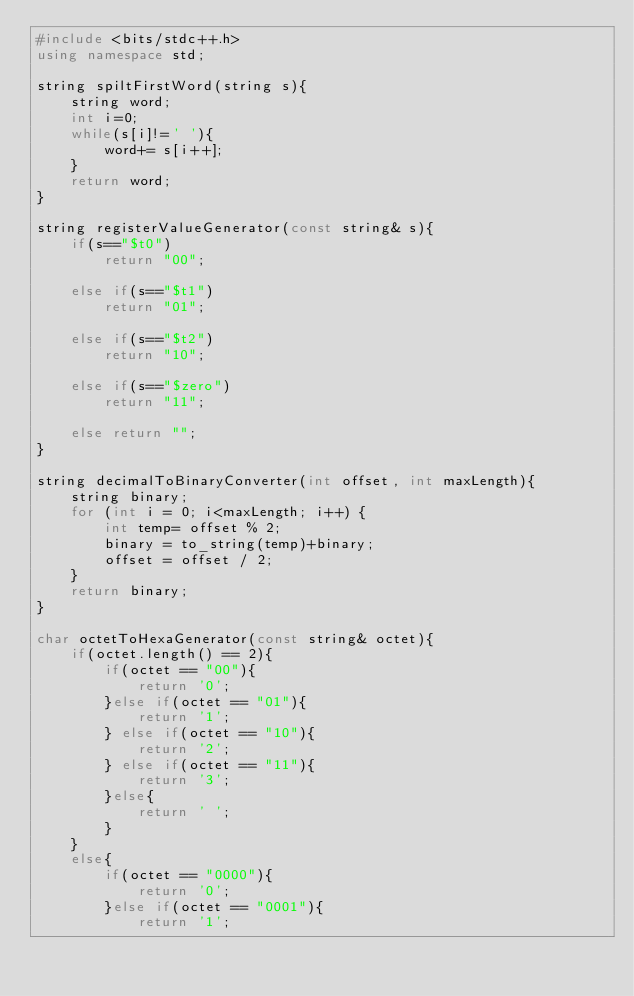Convert code to text. <code><loc_0><loc_0><loc_500><loc_500><_C++_>#include <bits/stdc++.h>
using namespace std;

string spiltFirstWord(string s){
    string word;
    int i=0;
    while(s[i]!=' '){
        word+= s[i++];
    }
    return word;
}

string registerValueGenerator(const string& s){
    if(s=="$t0")
        return "00";

    else if(s=="$t1")
        return "01";

    else if(s=="$t2")
        return "10";

    else if(s=="$zero")
        return "11";

    else return "";
}

string decimalToBinaryConverter(int offset, int maxLength){
    string binary;
    for (int i = 0; i<maxLength; i++) {
        int temp= offset % 2;
        binary = to_string(temp)+binary;
        offset = offset / 2;
    }
    return binary;
}

char octetToHexaGenerator(const string& octet){
    if(octet.length() == 2){
        if(octet == "00"){
            return '0';
        }else if(octet == "01"){
            return '1';
        } else if(octet == "10"){
            return '2';
        } else if(octet == "11"){
            return '3';
        }else{
            return ' ';
        }
    }
    else{
        if(octet == "0000"){
            return '0';
        }else if(octet == "0001"){
            return '1';</code> 